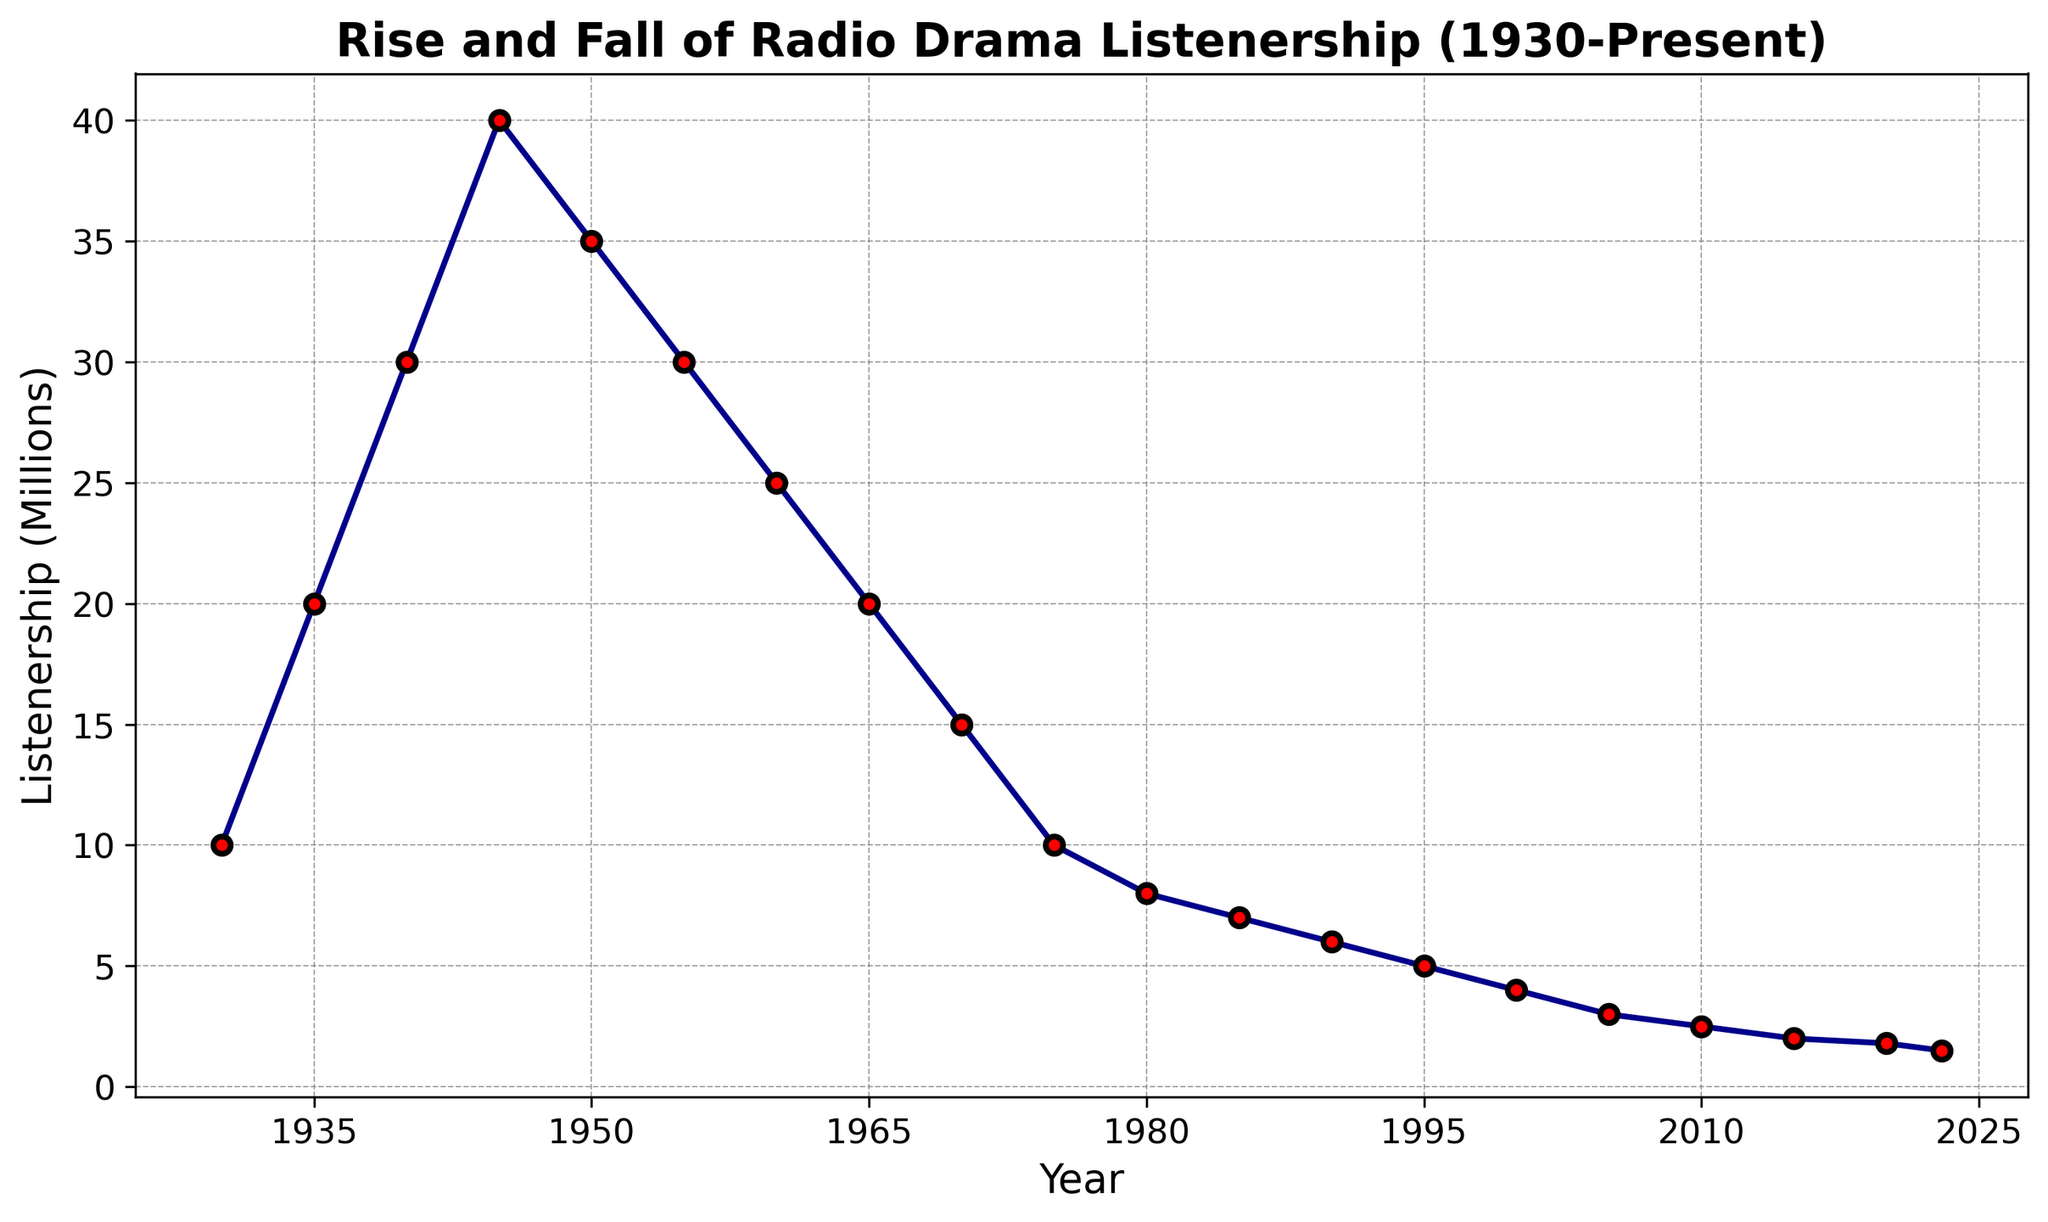Which year had the peak listenership for radio dramas? The peak listenership can be identified by looking for the highest point on the line which appears in 1945 with 40 million listeners.
Answer: 1945 What is the difference in listenership between 1945 and 2023? The listenership in 1945 was 40 million, while in 2023 it was 1.5 million. The difference is calculated as 40 - 1.5 = 38.5 million.
Answer: 38.5 million How did the listenership change from 1950 to 1960? Looking at the y-values at 1950 (35 million) and 1960 (25 million), the change can be calculated as 25 - 35 = -10 million, indicating a decrease.
Answer: Decreased by 10 million What is the average listenership between 1930 and 1940? The listenerships are 10, 20, and 30 million for 1930, 1935, and 1940 respectively. The average is calculated as (10 + 20 + 30) / 3 = 20 million.
Answer: 20 million In which decade did listenership decline the most? Look at the declining values decade by decade (1950-1960, 1960-1970, etc.). The largest drop is between 1945 (40 million) and 1955 (30 million), a decline of 10 million in the 1950s.
Answer: 1950s How does the listenership in 2015 compare to that in 2020? The listenership in 2015 was 2 million, and it was 1.8 million in 2020. Comparing these values shows a slight decrease of 0.2 million by 2020.
Answer: Decreased by 0.2 million What is the rate of decline in listenership from 1980 to 1990? Listenership in 1980 was 8 million, and in 1990 it was 6 million. The decline over 10 years is 8 - 6 = 2 million. The annual rate of decline is 2 million / 10 years = 0.2 million per year.
Answer: 0.2 million per year Which color and shape represent the data points on the chart? The visual attributes of the chart show the data points as red circles with black edges connected by a dark blue line.
Answer: Red circles with black edges and dark blue line If the trend from 2020 to 2023 continues, what might be the listenership in 2026? The rate from 2020 (1.8 million) to 2023 (1.5 million) is a decline of 1.5-1.8 = -0.3 million in 3 years, or 0.1 million per year. Extrapolating to 2026 (3 more years), the listenership might be 1.5 - 0.3 = 1.2 million.
Answer: 1.2 million What years had the same listenership values? Looking across the chart, the listenership in 1935 (20 million) is equal to that in 1965 (20 million).
Answer: 1935 and 1965 